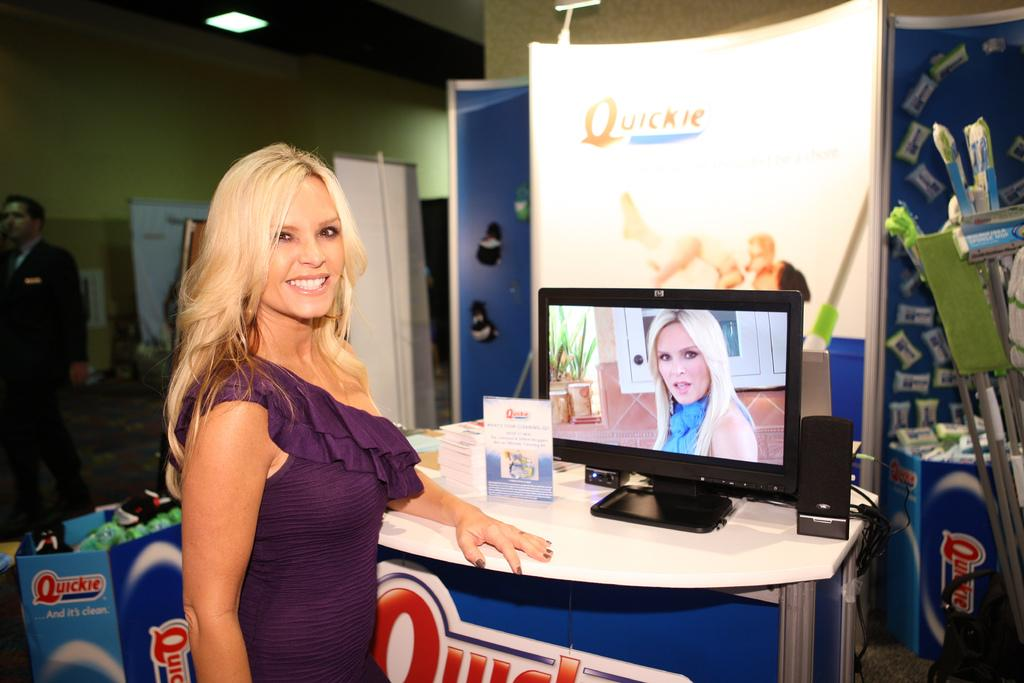<image>
Give a short and clear explanation of the subsequent image. A woman stands near a "Quickie" booth with a tv monitor on it. 